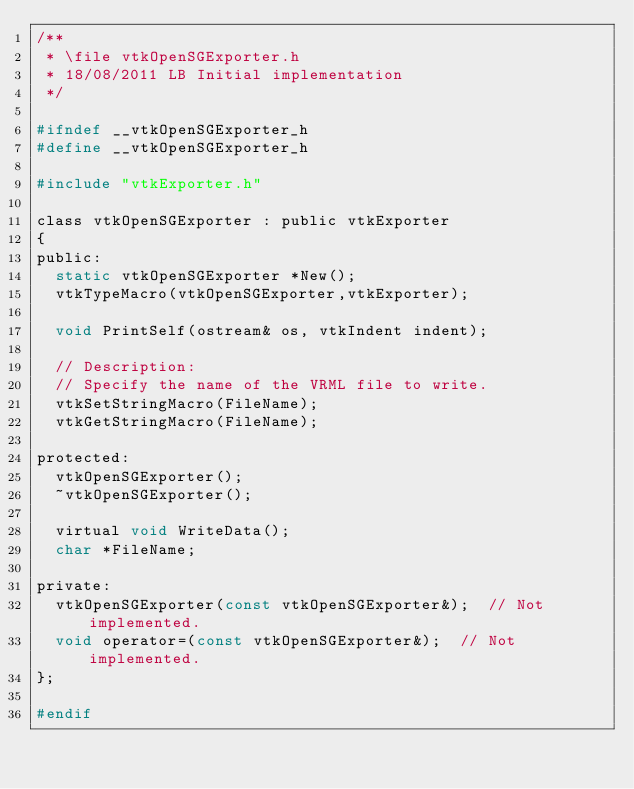<code> <loc_0><loc_0><loc_500><loc_500><_C_>/**
 * \file vtkOpenSGExporter.h
 * 18/08/2011 LB Initial implementation
 */

#ifndef __vtkOpenSGExporter_h
#define __vtkOpenSGExporter_h

#include "vtkExporter.h"

class vtkOpenSGExporter : public vtkExporter
{
public:
  static vtkOpenSGExporter *New();
  vtkTypeMacro(vtkOpenSGExporter,vtkExporter);

  void PrintSelf(ostream& os, vtkIndent indent);

  // Description:
  // Specify the name of the VRML file to write.
  vtkSetStringMacro(FileName);
  vtkGetStringMacro(FileName);

protected:
  vtkOpenSGExporter();
  ~vtkOpenSGExporter();

  virtual void WriteData();
  char *FileName;

private:
  vtkOpenSGExporter(const vtkOpenSGExporter&);  // Not implemented.
  void operator=(const vtkOpenSGExporter&);  // Not implemented.
};

#endif
</code> 